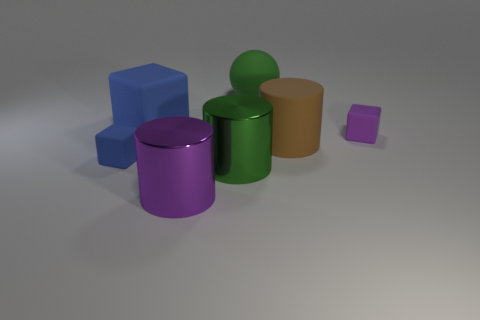Add 1 matte blocks. How many objects exist? 8 Subtract all cylinders. How many objects are left? 4 Add 7 blue balls. How many blue balls exist? 7 Subtract 0 green blocks. How many objects are left? 7 Subtract all small gray metal blocks. Subtract all big purple metal objects. How many objects are left? 6 Add 6 brown matte objects. How many brown matte objects are left? 7 